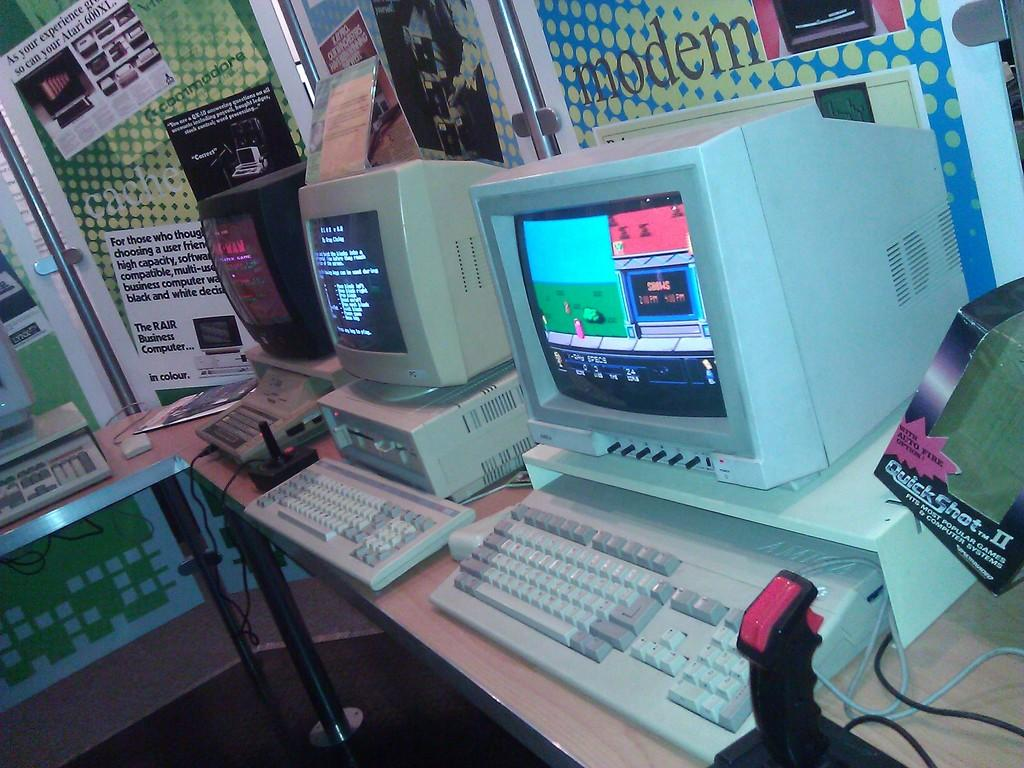<image>
Render a clear and concise summary of the photo. Some old style computers and a box reading Quick Shot to the right 